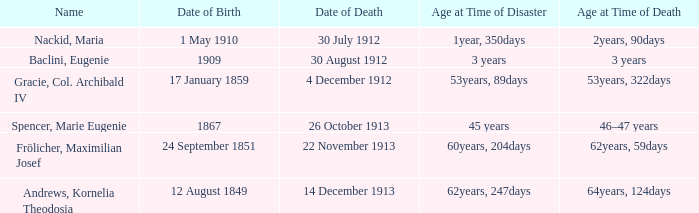What is the name of the person born in 1909? Baclini, Eugenie. 